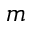<formula> <loc_0><loc_0><loc_500><loc_500>m</formula> 